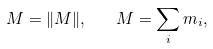<formula> <loc_0><loc_0><loc_500><loc_500>M = \| { M } \| , \quad M = \sum _ { i } { m _ { i } } ,</formula> 